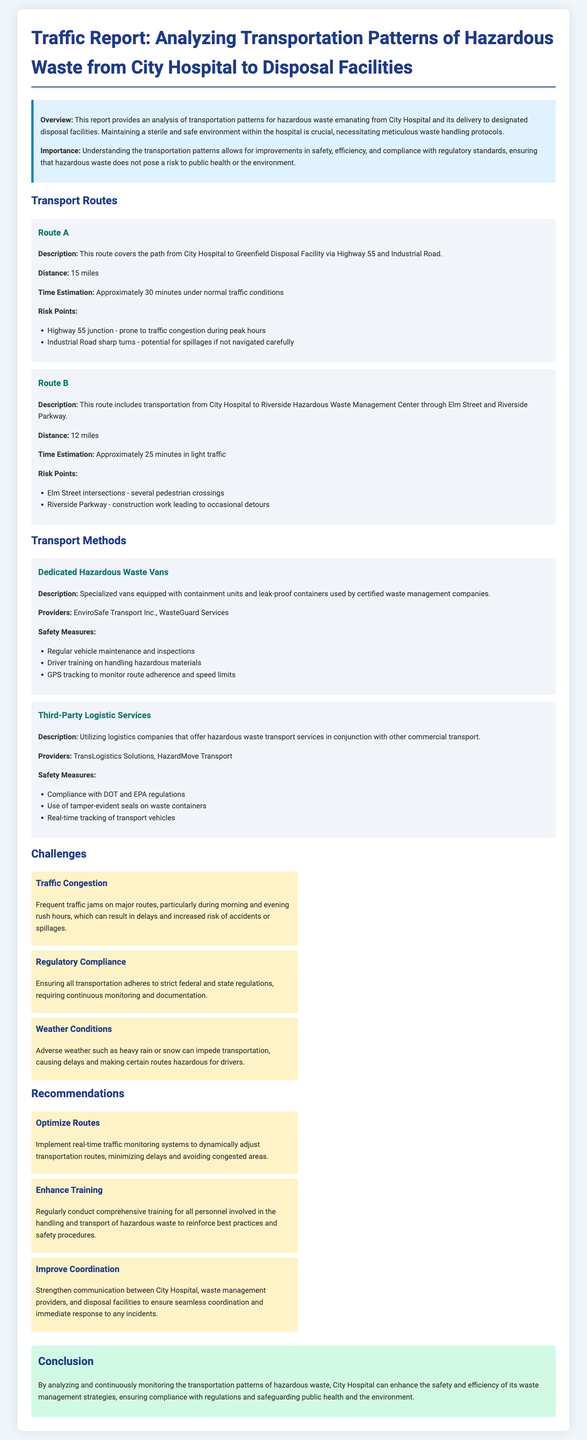What is the distance of Route A? The distance of Route A from City Hospital to Greenfield Disposal Facility is mentioned as 15 miles.
Answer: 15 miles What are the risk points for Route B? The document lists risk points for Route B, which include several pedestrian crossings on Elm Street and construction work on Riverside Parkway.
Answer: Elm Street intersections, Riverside Parkway What is the time estimation for Route A? The report provides a time estimation of approximately 30 minutes for Route A under normal traffic conditions.
Answer: Approximately 30 minutes Which company provides dedicated hazardous waste vans? The document mentions "EnviroSafe Transport Inc." and "WasteGuard Services" as providers of specialized vans for hazardous waste transportation.
Answer: EnviroSafe Transport Inc., WasteGuard Services What is one challenge faced in transporting hazardous waste? The report outlines several challenges, with traffic congestion being a significant issue that leads to delays and risks.
Answer: Traffic Congestion How many miles does Route B cover? The document specifies that Route B covers a distance of 12 miles from City Hospital to Riverside Hazardous Waste Management Center.
Answer: 12 miles What safety measure is highlighted for dedicated hazardous waste vans? Regular vehicle maintenance and inspections are emphasized as a safety measure in the report for specialized vans.
Answer: Regular vehicle maintenance and inspections What is the conclusion of the traffic report? The conclusion stresses the importance of analyzing and continuously monitoring transportation patterns to enhance safety and efficiency in waste management strategies.
Answer: Enhance safety and efficiency in waste management strategies 